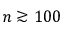<formula> <loc_0><loc_0><loc_500><loc_500>n \gtrsim 1 0 0</formula> 